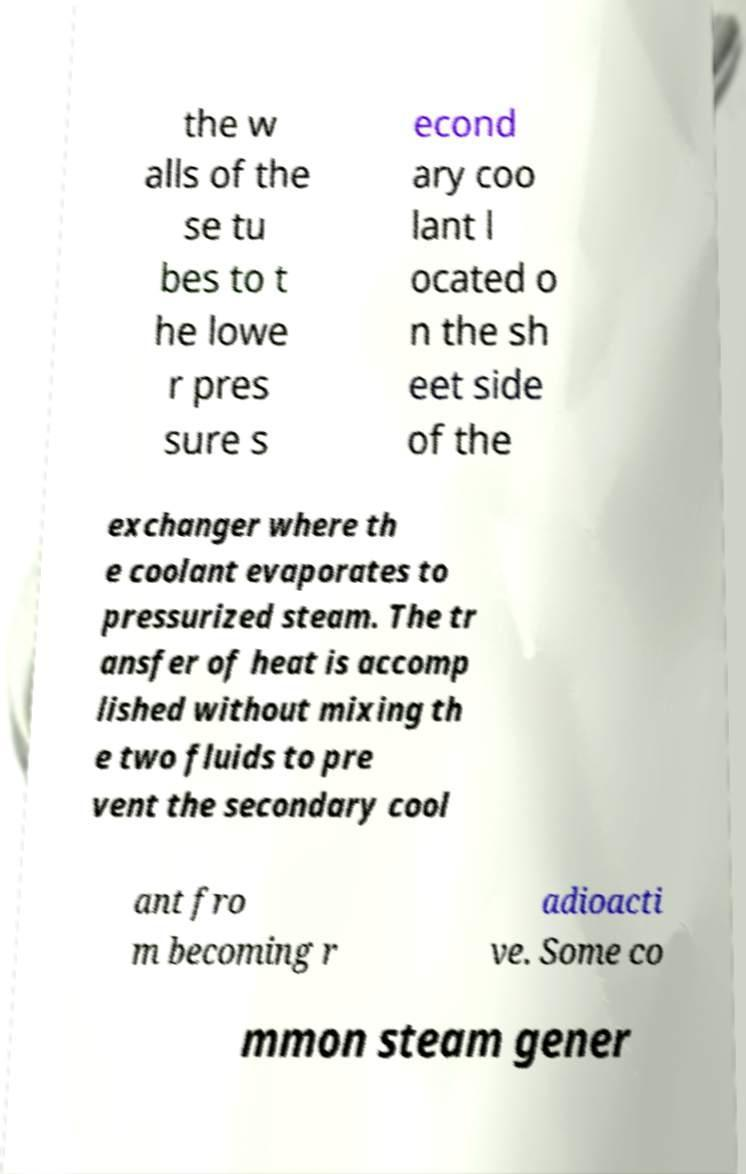Please read and relay the text visible in this image. What does it say? the w alls of the se tu bes to t he lowe r pres sure s econd ary coo lant l ocated o n the sh eet side of the exchanger where th e coolant evaporates to pressurized steam. The tr ansfer of heat is accomp lished without mixing th e two fluids to pre vent the secondary cool ant fro m becoming r adioacti ve. Some co mmon steam gener 